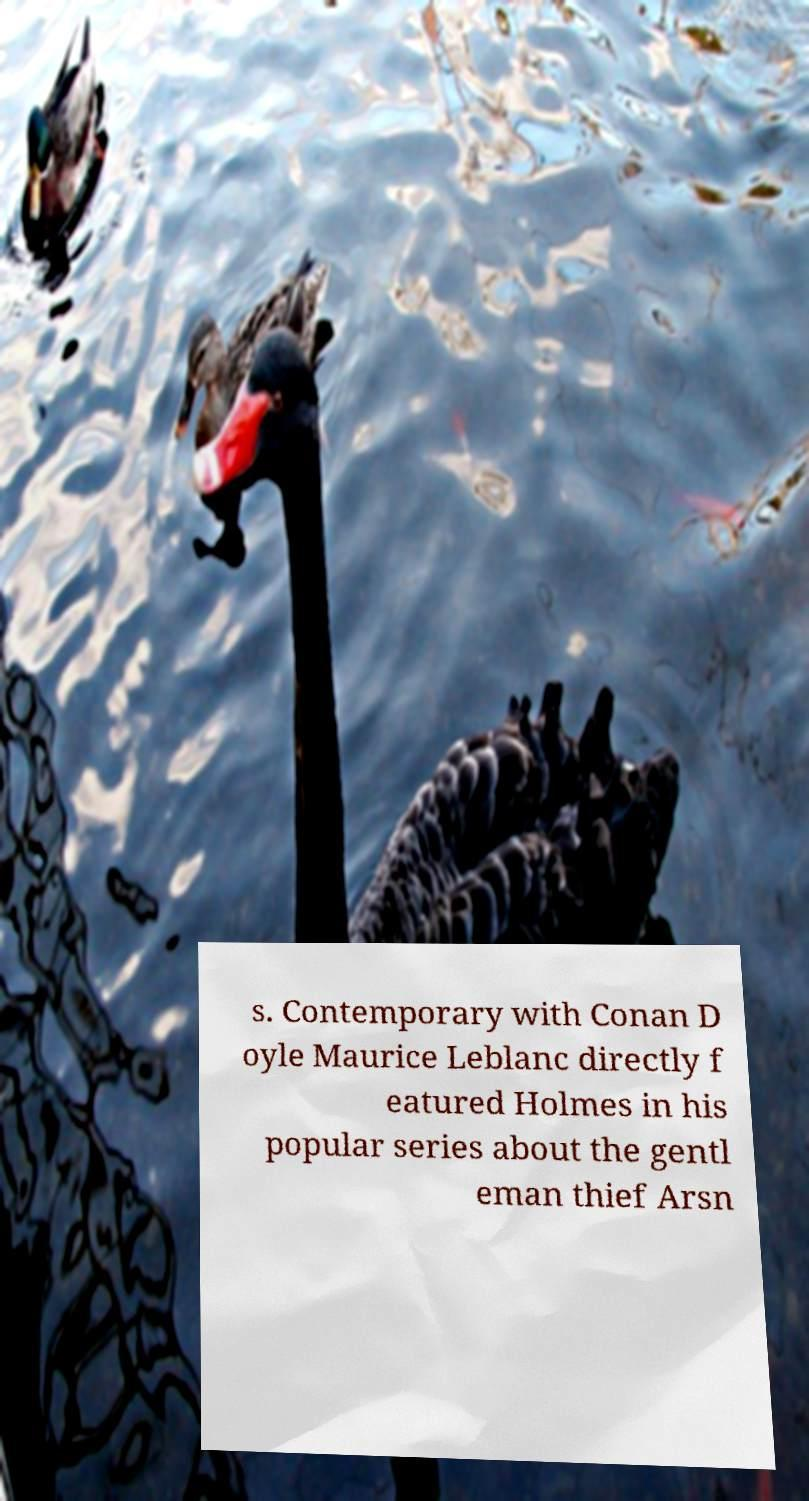Can you accurately transcribe the text from the provided image for me? s. Contemporary with Conan D oyle Maurice Leblanc directly f eatured Holmes in his popular series about the gentl eman thief Arsn 